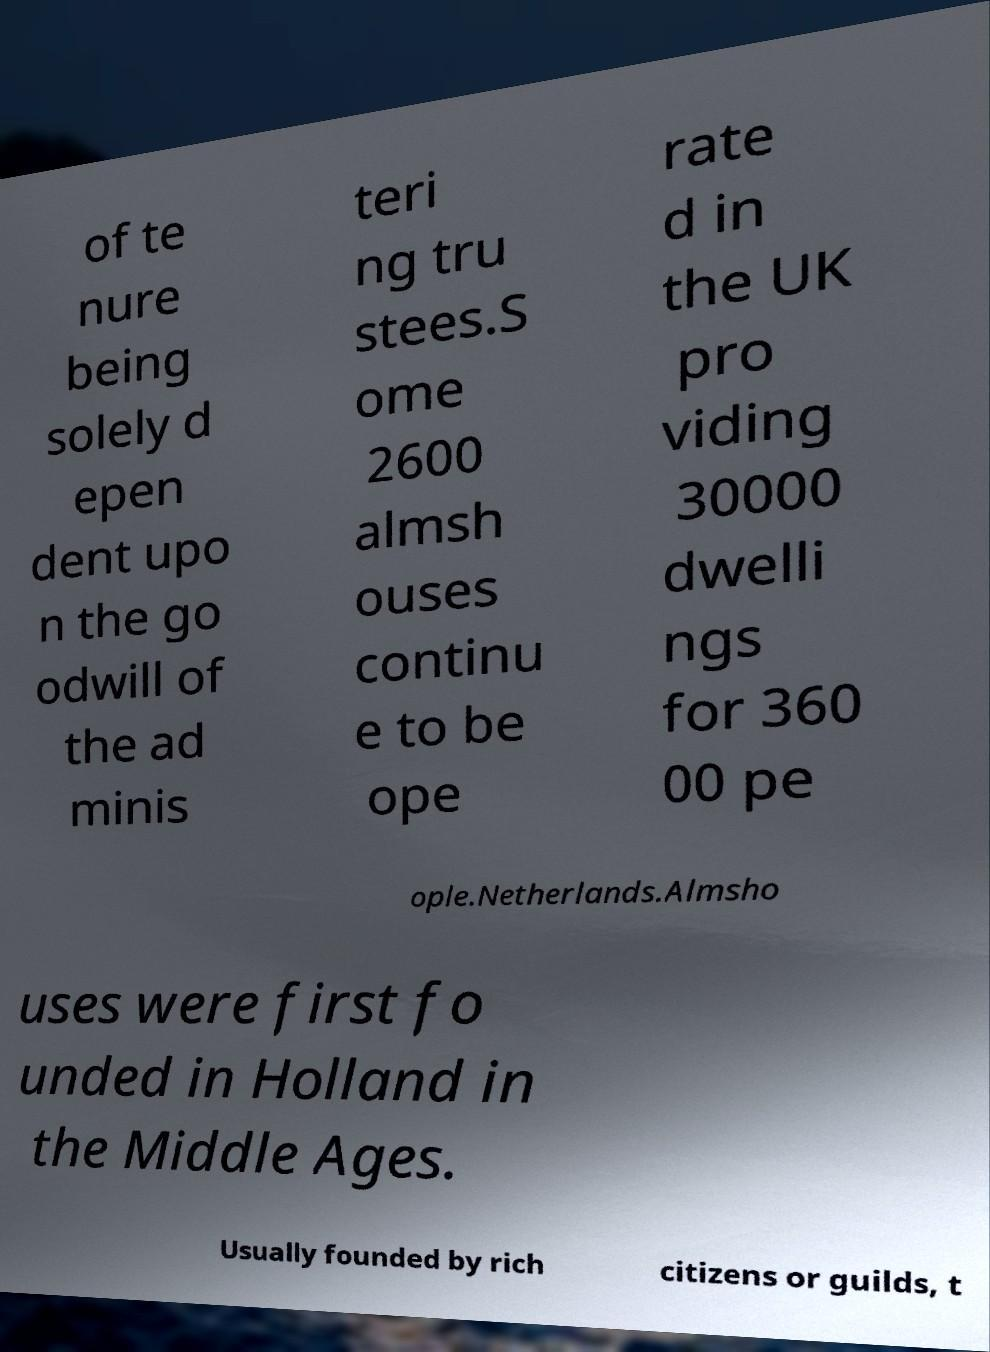Can you accurately transcribe the text from the provided image for me? of te nure being solely d epen dent upo n the go odwill of the ad minis teri ng tru stees.S ome 2600 almsh ouses continu e to be ope rate d in the UK pro viding 30000 dwelli ngs for 360 00 pe ople.Netherlands.Almsho uses were first fo unded in Holland in the Middle Ages. Usually founded by rich citizens or guilds, t 